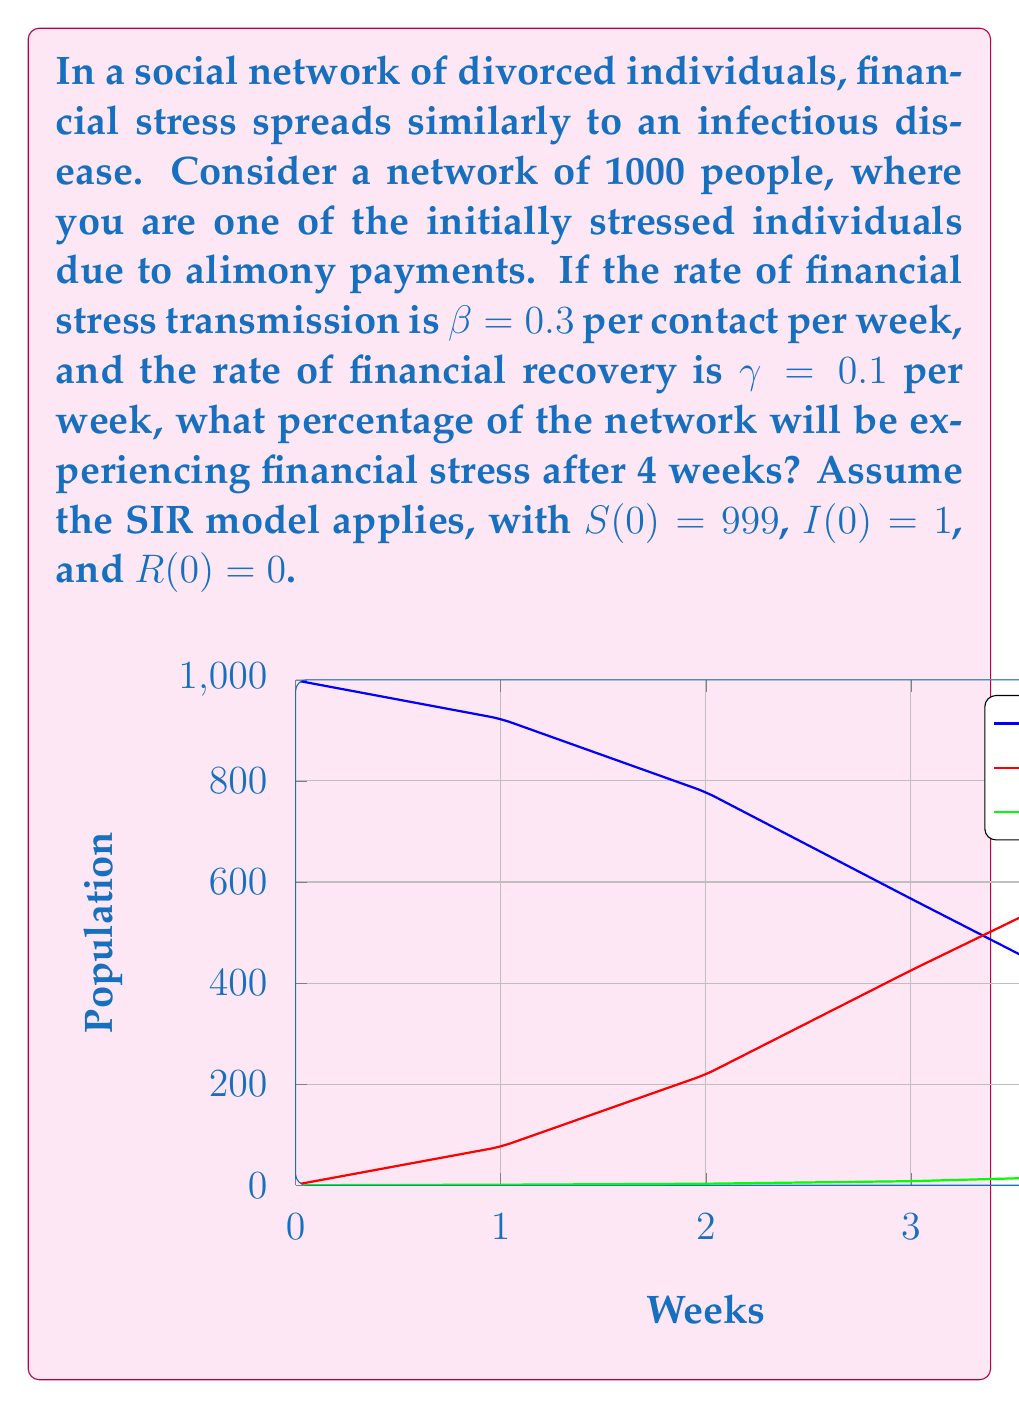Help me with this question. To solve this problem, we'll use the SIR model equations:

$$\frac{dS}{dt} = -\beta SI$$
$$\frac{dI}{dt} = \beta SI - \gamma I$$
$$\frac{dR}{dt} = \gamma I$$

Where:
S = Susceptible individuals
I = Infected (financially stressed) individuals
R = Recovered individuals
β = Transmission rate
γ = Recovery rate

Given:
- Total population N = 1000
- β = 0.3 per contact per week
- γ = 0.1 per week
- Initial conditions: S(0) = 999, I(0) = 1, R(0) = 0
- Time t = 4 weeks

Step 1: Calculate the basic reproduction number R₀:
$$R_0 = \frac{\beta N}{\gamma} = \frac{0.3 \times 1000}{0.1} = 3000$$

Step 2: Since R₀ > 1, we expect the financial stress to spread.

Step 3: Use a numerical method (e.g., Runge-Kutta) to solve the differential equations for t = 4 weeks. The graph in the question shows the approximate results.

Step 4: From the graph, we can estimate that after 4 weeks:
S ≈ 359
I ≈ 622
R ≈ 19

Step 5: Calculate the percentage of the network experiencing financial stress:
Percentage = (I / N) × 100 = (622 / 1000) × 100 = 62.2%
Answer: 62.2% 